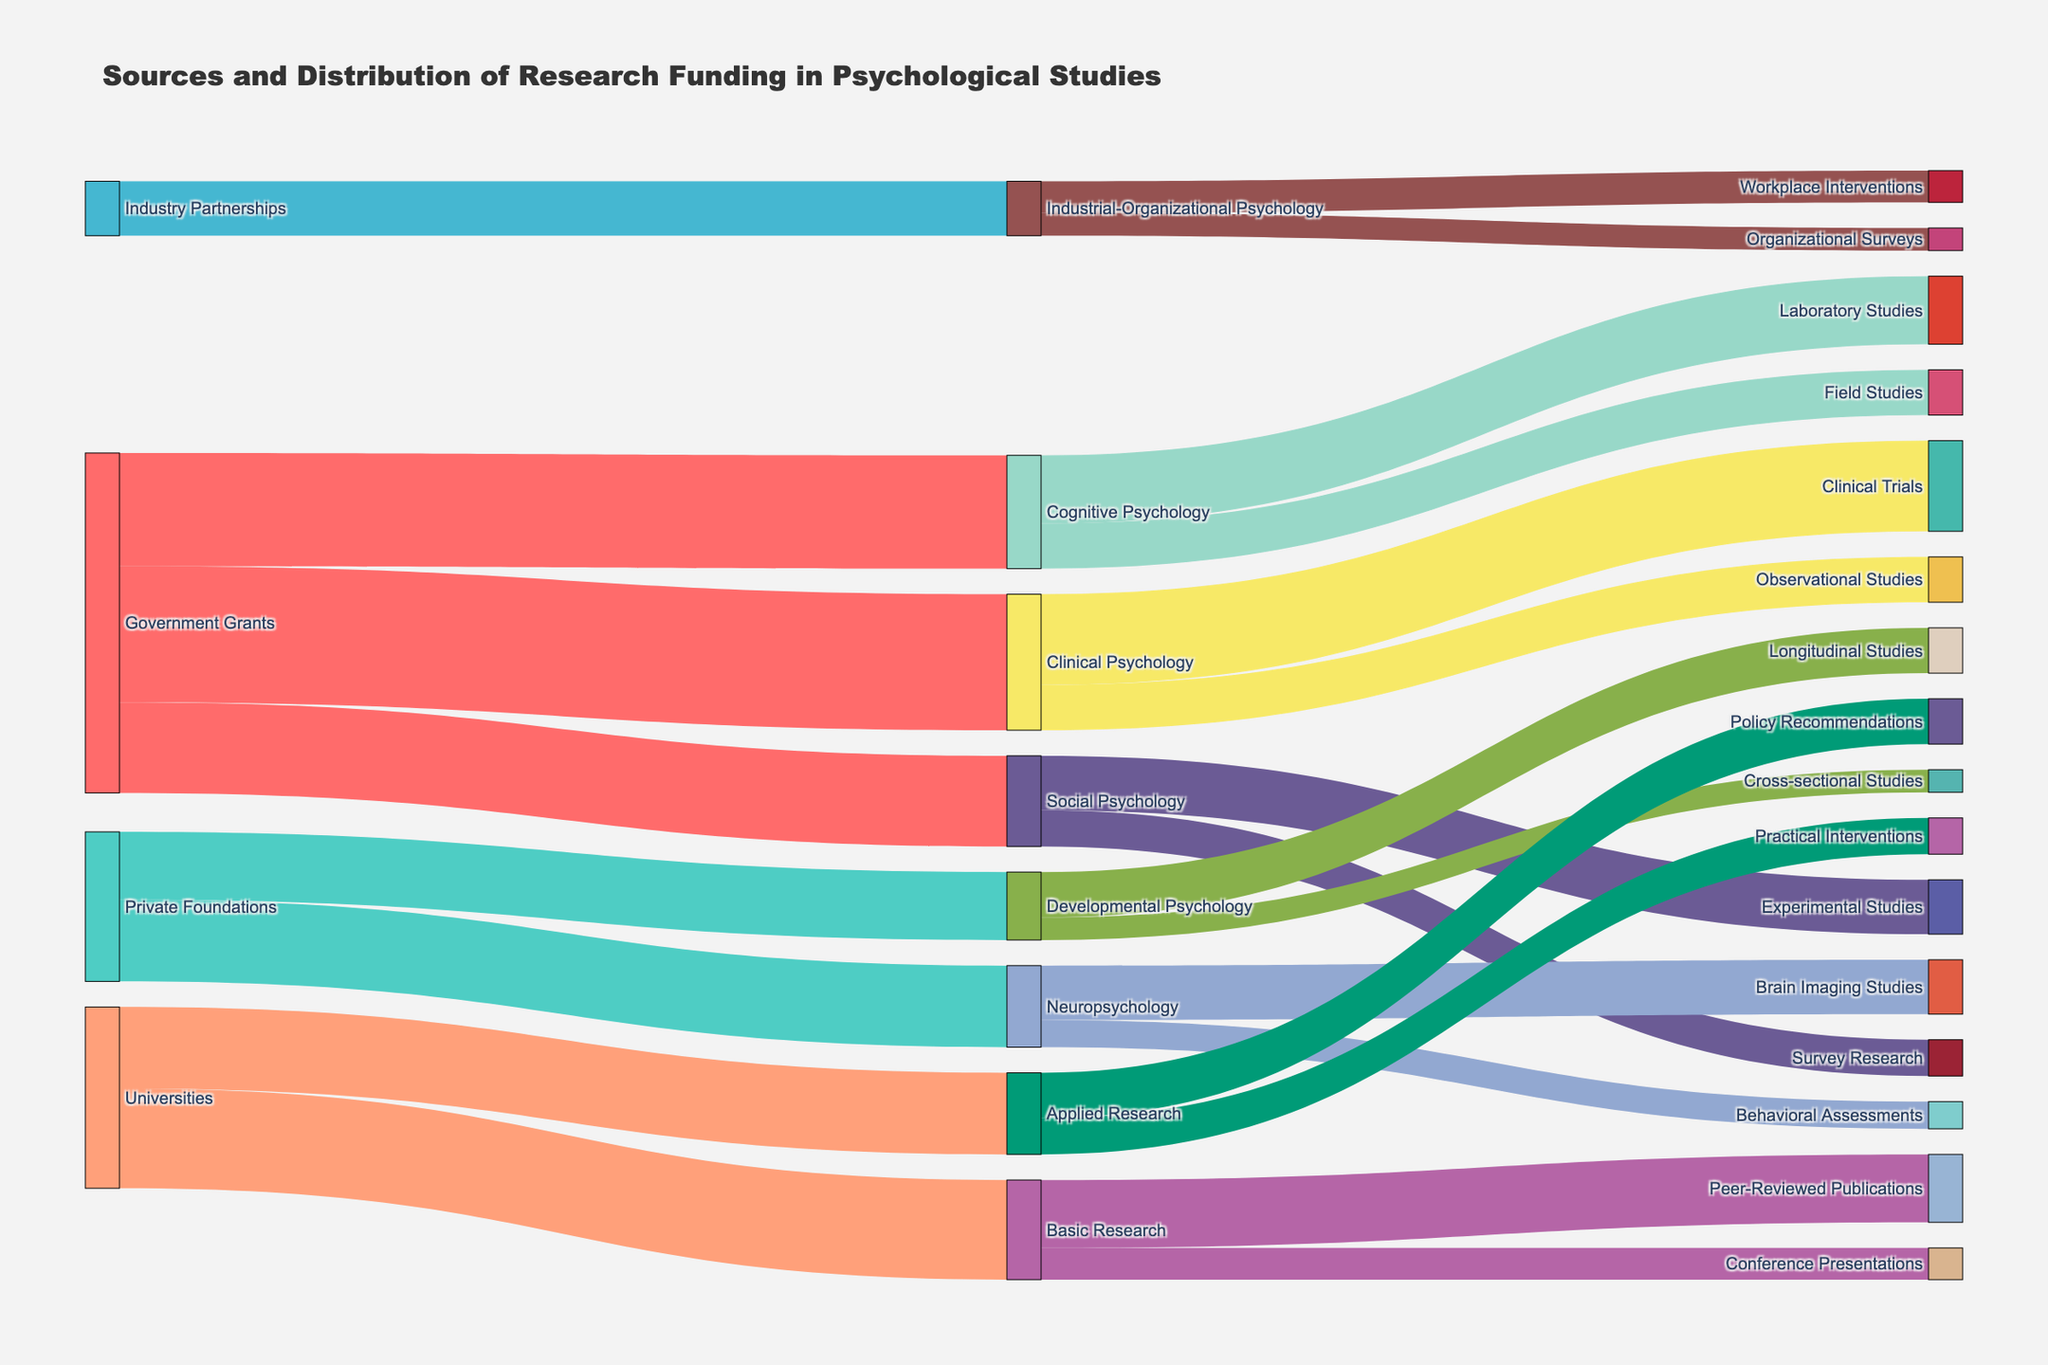what is the title of the figure? The title is usually displayed prominently at the top of the figure. By reading it, we can identify what the figure is about. In this case, the title is "Sources and Distribution of Research Funding in Psychological Studies."
Answer: Sources and Distribution of Research Funding in Psychological Studies what color represents "Government Grants"? To determine this, look at the color assigned to "Government Grants" in the Sankey diagram. The color is used consistently for all nodes related to "Government Grants."
Answer: Red how many funding sources are shown in the figure? The funding sources are the first-level nodes from which the funding flows. These are "Government Grants," "Private Foundations," "Industry Partnerships," and "Universities." Counting these, we get four funding sources.
Answer: Four which funding source provides the most funding to "Clinical Psychology"? By examining the connections flowing into "Clinical Psychology," we see that "Government Grants" has the largest value of 30. We determine this by comparing the values of the links.
Answer: Government Grants what is the total amount of funding received by "Applied Research"? To find the total funding for "Applied Research," look at the nodes leading into it, which is "Universities." The figure shows "Universities" provide 18 units of funding to "Applied Research."
Answer: 18 how is the funding from "Government Grants" distributed across psychological studies? By following the links from "Government Grants," we see it distributes its funds to "Cognitive Psychology" (25), "Clinical Psychology" (30), and "Social Psychology" (20). Adding these gives the total distribution.
Answer: 25 to Cognitive Psychology, 30 to Clinical Psychology, 20 to Social Psychology compare funding between "Laboratory Studies" and "Field Studies" under "Cognitive Psychology"? Under "Cognitive Psychology," "Laboratory Studies" receives 15 units and "Field Studies" receives 10 units. Therefore, "Laboratory Studies" receives more funding.
Answer: Laboratory Studies receives more how does the funding from "Private Foundations" split between "Developmental Psychology" and "Neuropsychology"? By tracing the paths from "Private Foundations," we see that 15 units go to "Developmental Psychology" and 18 units go to "Neuropsychology." This tells us how the total is split.
Answer: 15 to Developmental Psychology, 18 to Neuropsychology what are the research outputs linked to "Basic Research"? The nodes connected to "Basic Research" are "Peer-Reviewed Publications" and "Conference Presentations."
Answer: Peer-Reviewed Publications and Conference Presentations 